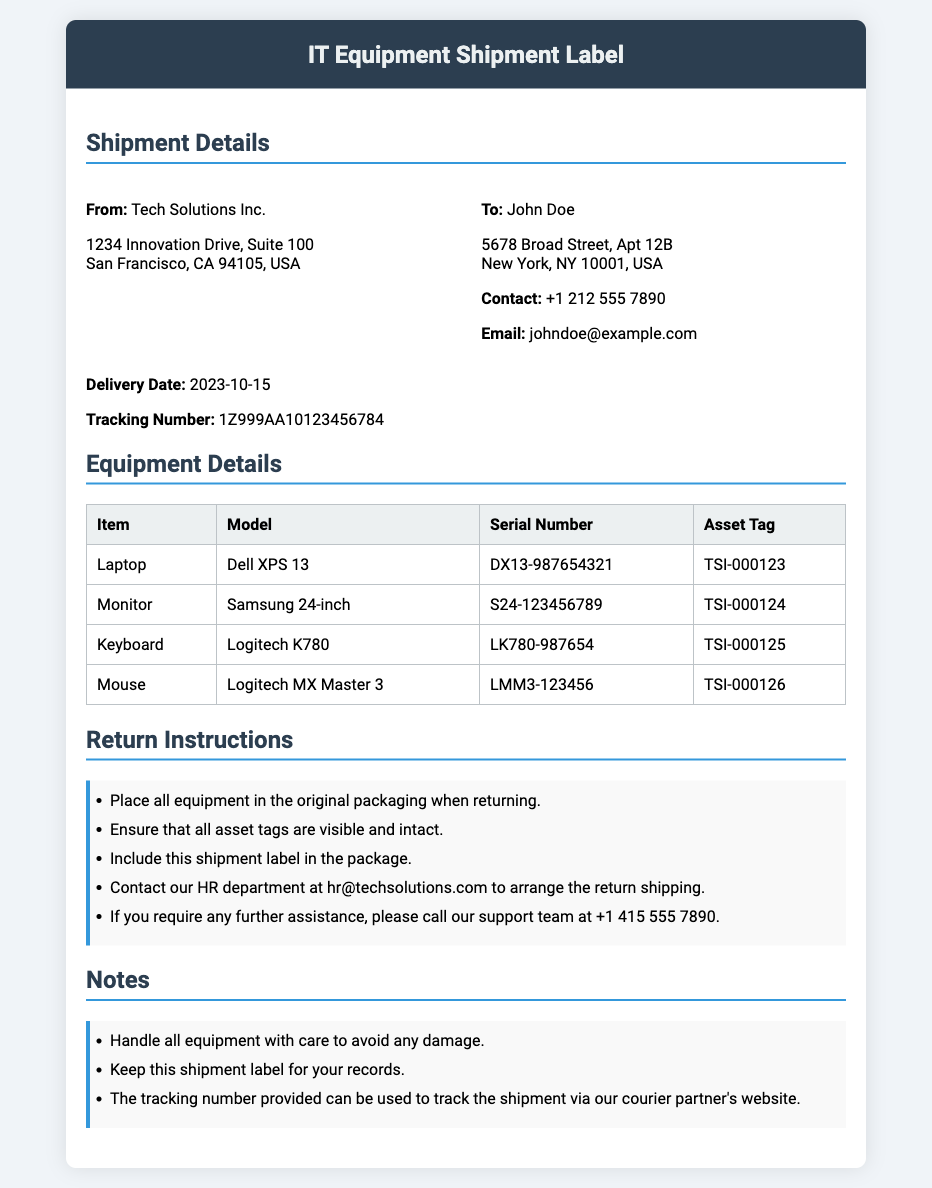What is the name of the sender? The sender's name is listed under "From:" in the shipment details.
Answer: Tech Solutions Inc What is the delivery date? The delivery date is specified clearly in the shipment details section.
Answer: 2023-10-15 What is the asset tag for the Laptop? Each item in the equipment list has an associated asset tag.
Answer: TSI-000123 Who should be contacted for return shipping arrangements? The contact information for return shipping arrangements is provided in the return instructions.
Answer: hr@techsolutions.com What item has the serial number S24-123456789? The serial number is used to identify specific items in the equipment details section.
Answer: Monitor How many items are listed in the equipment details? The number of items can be counted from the equipment list in the document.
Answer: 4 What instructions are given regarding the visibility of asset tags? Specific guidance on handling asset tags is included in the return instructions.
Answer: Ensure that all asset tags are visible and intact What should be included in the package when returning the equipment? The return instructions specify what to include when returning equipment.
Answer: This shipment label 